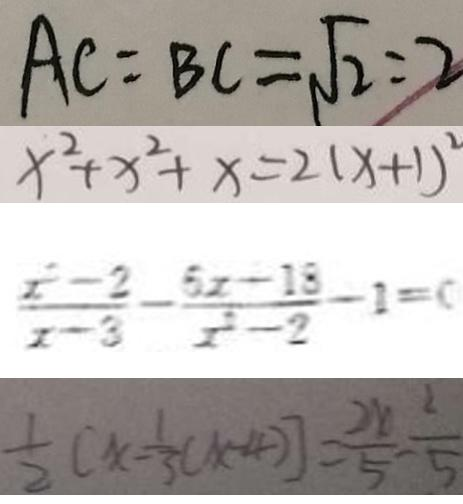<formula> <loc_0><loc_0><loc_500><loc_500>A C = B C = \sqrt { 2 } : 2 
 x ^ { 2 } + x ^ { 2 } + x = 2 ( x + 1 ) ^ { 2 } 
 \frac { x ^ { 2 } - 2 } { x - 3 } - \frac { 5 x - 1 8 } { x ^ { 2 } - 2 } - 1 = 0 
 \frac { 1 } { 2 } ( x - \frac { 1 } { 3 } ( x - 4 ) ] = \frac { 2 x } { 5 } - \frac { 2 } { 5 }</formula> 